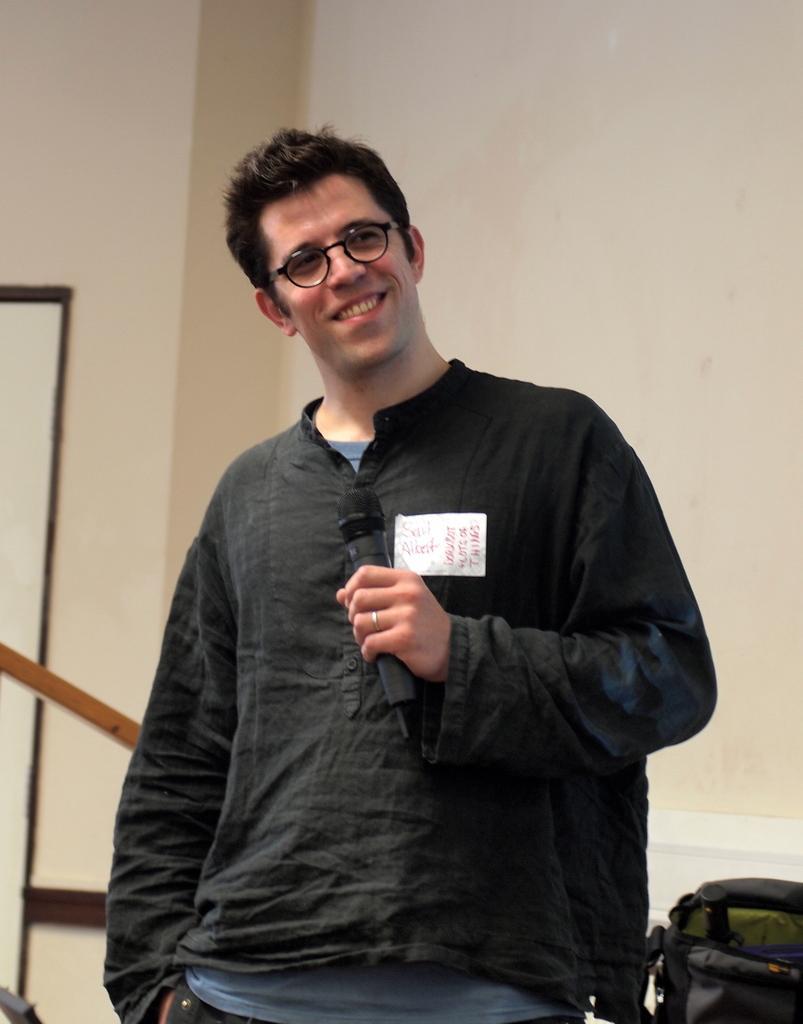Describe this image in one or two sentences. This picture is mainly highlighted with a man standing and holding a mike in his hand. He wore spectacles. This is a bag. On the background we can see a wall. 